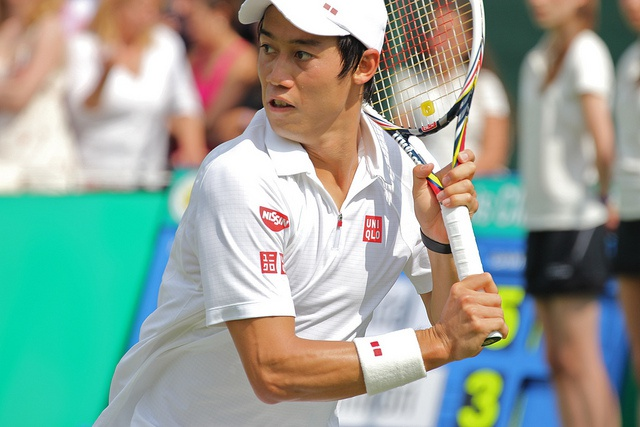Describe the objects in this image and their specific colors. I can see people in maroon, white, darkgray, gray, and tan tones, people in maroon, darkgray, black, gray, and lightgray tones, people in maroon, lightgray, darkgray, and salmon tones, tennis racket in maroon, white, darkgray, brown, and black tones, and people in maroon, ivory, tan, darkgray, and salmon tones in this image. 